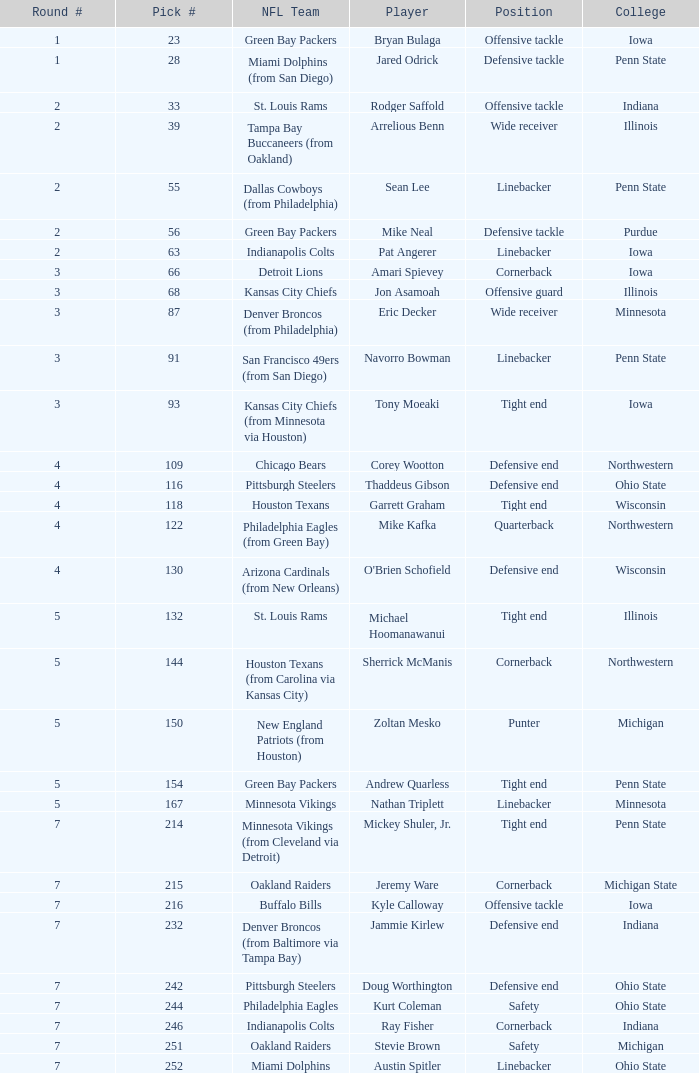On how many nfl teams does stevie brown perform? 1.0. 